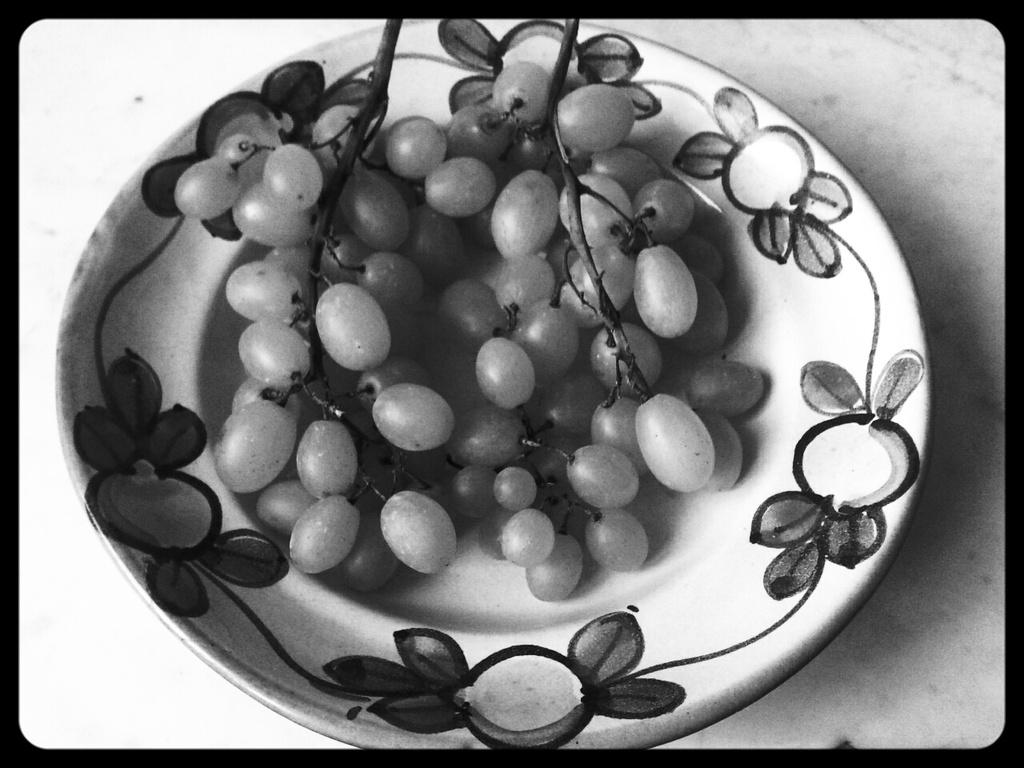What type of fruit is on the plate in the image? There is a grape on a plate in the image. Where is the grape and plate located? The grape and plate are placed on a table. What type of spacecraft can be seen in the image? There is no spacecraft present in the image; it features a grape on a plate placed on a table. How many police officers are visible in the image? There are no police officers present in the image; it features a grape on a plate placed on a table. 